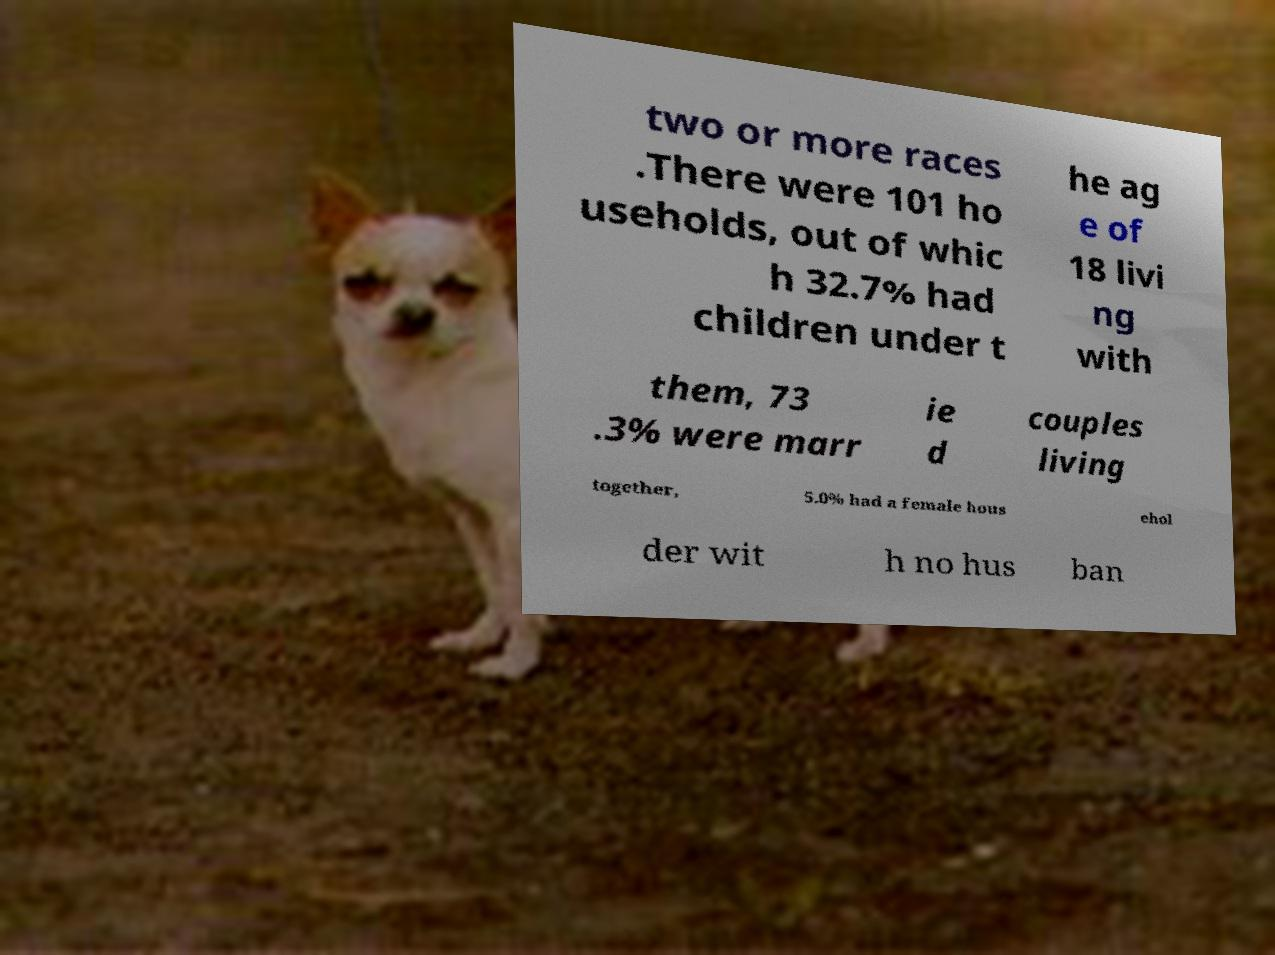For documentation purposes, I need the text within this image transcribed. Could you provide that? two or more races .There were 101 ho useholds, out of whic h 32.7% had children under t he ag e of 18 livi ng with them, 73 .3% were marr ie d couples living together, 5.0% had a female hous ehol der wit h no hus ban 